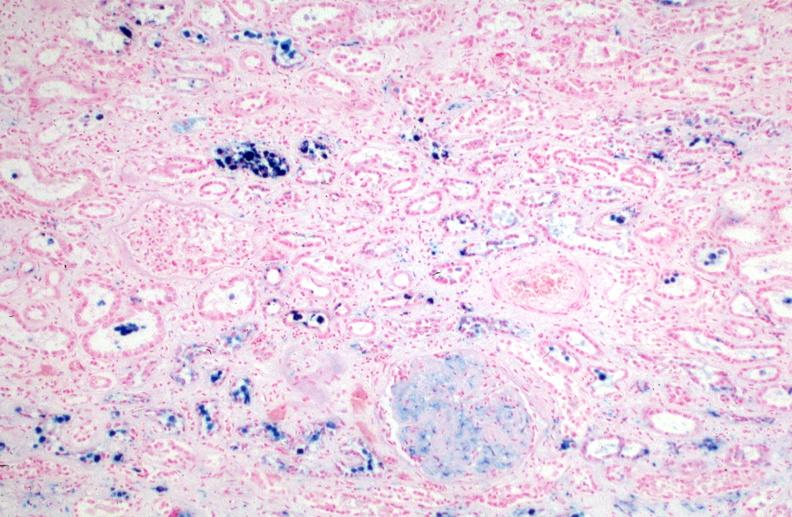where is this?
Answer the question using a single word or phrase. Urinary 